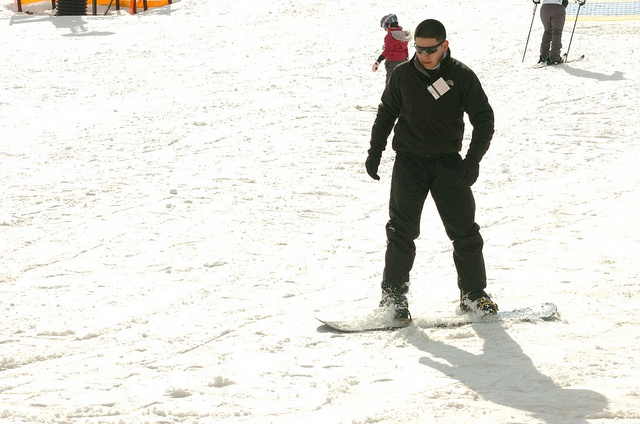Describe the objects in this image and their specific colors. I can see people in white, black, ivory, gray, and darkgray tones, snowboard in white, ivory, darkgray, lightgray, and gray tones, people in white, gray, black, and lightgray tones, people in white, brown, maroon, gray, and darkgray tones, and skis in white, black, ivory, gray, and darkgray tones in this image. 